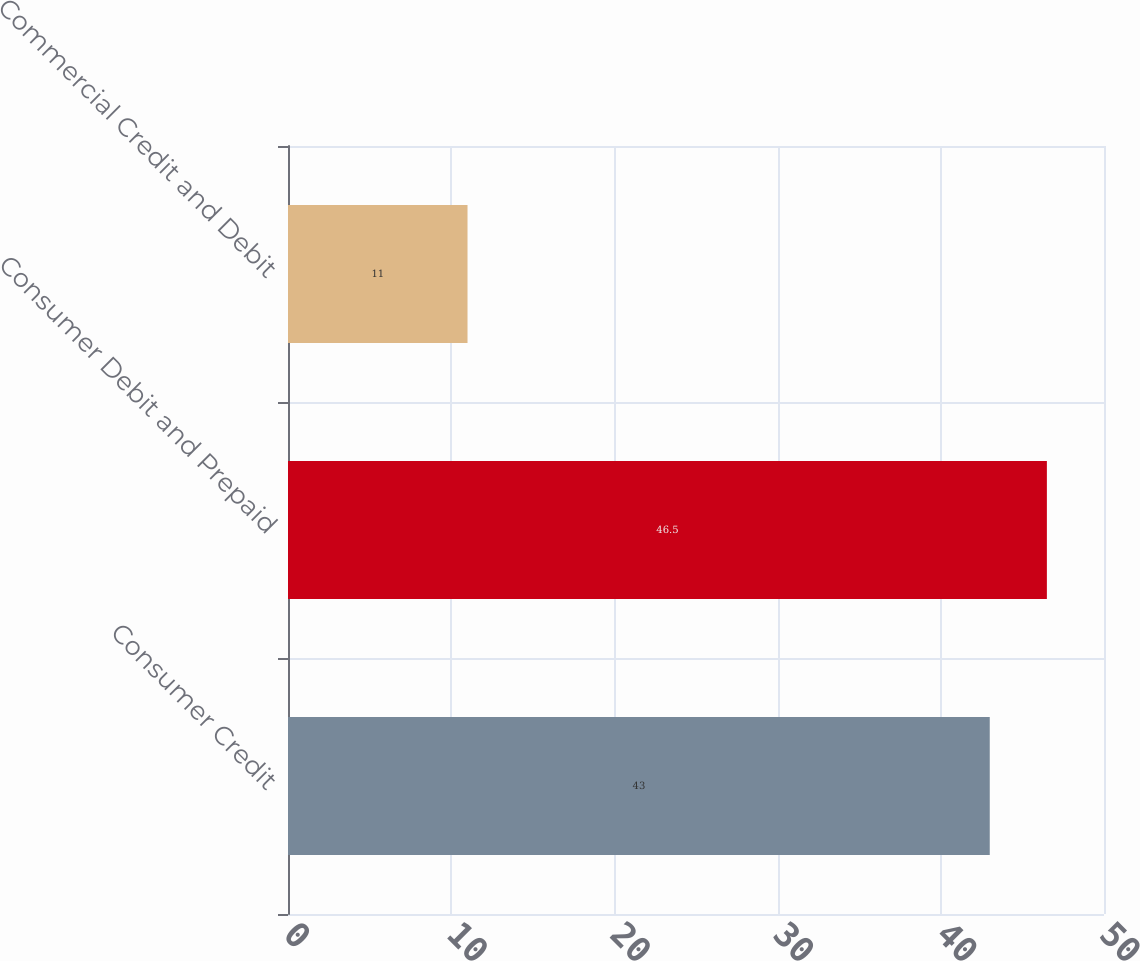Convert chart to OTSL. <chart><loc_0><loc_0><loc_500><loc_500><bar_chart><fcel>Consumer Credit<fcel>Consumer Debit and Prepaid<fcel>Commercial Credit and Debit<nl><fcel>43<fcel>46.5<fcel>11<nl></chart> 